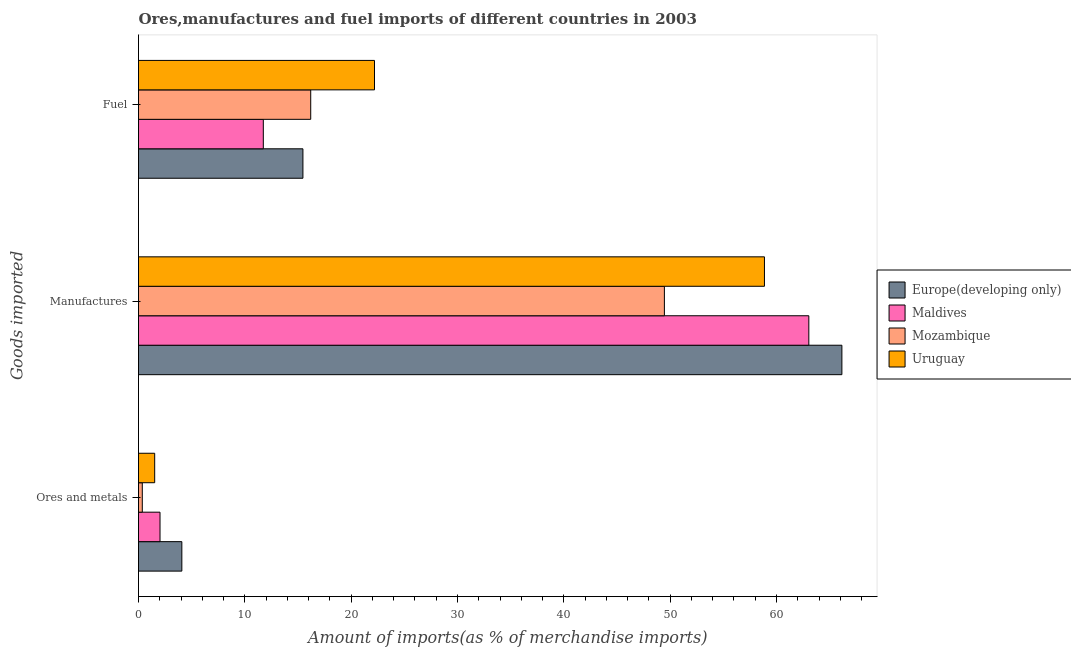How many different coloured bars are there?
Provide a short and direct response. 4. Are the number of bars per tick equal to the number of legend labels?
Give a very brief answer. Yes. Are the number of bars on each tick of the Y-axis equal?
Ensure brevity in your answer.  Yes. How many bars are there on the 3rd tick from the bottom?
Make the answer very short. 4. What is the label of the 1st group of bars from the top?
Make the answer very short. Fuel. What is the percentage of ores and metals imports in Maldives?
Give a very brief answer. 2.02. Across all countries, what is the maximum percentage of fuel imports?
Provide a succinct answer. 22.19. Across all countries, what is the minimum percentage of fuel imports?
Provide a succinct answer. 11.74. In which country was the percentage of fuel imports maximum?
Ensure brevity in your answer.  Uruguay. In which country was the percentage of ores and metals imports minimum?
Provide a short and direct response. Mozambique. What is the total percentage of fuel imports in the graph?
Your answer should be compact. 65.59. What is the difference between the percentage of fuel imports in Mozambique and that in Europe(developing only)?
Ensure brevity in your answer.  0.73. What is the difference between the percentage of ores and metals imports in Maldives and the percentage of fuel imports in Uruguay?
Give a very brief answer. -20.17. What is the average percentage of ores and metals imports per country?
Ensure brevity in your answer.  1.99. What is the difference between the percentage of manufactures imports and percentage of ores and metals imports in Europe(developing only)?
Offer a terse response. 62.07. What is the ratio of the percentage of manufactures imports in Maldives to that in Europe(developing only)?
Offer a very short reply. 0.95. What is the difference between the highest and the second highest percentage of ores and metals imports?
Offer a very short reply. 2.05. What is the difference between the highest and the lowest percentage of fuel imports?
Your answer should be very brief. 10.46. What does the 2nd bar from the top in Ores and metals represents?
Provide a short and direct response. Mozambique. What does the 3rd bar from the bottom in Ores and metals represents?
Your answer should be compact. Mozambique. Is it the case that in every country, the sum of the percentage of ores and metals imports and percentage of manufactures imports is greater than the percentage of fuel imports?
Your answer should be compact. Yes. Are all the bars in the graph horizontal?
Give a very brief answer. Yes. Where does the legend appear in the graph?
Your answer should be very brief. Center right. How many legend labels are there?
Provide a succinct answer. 4. What is the title of the graph?
Offer a very short reply. Ores,manufactures and fuel imports of different countries in 2003. What is the label or title of the X-axis?
Keep it short and to the point. Amount of imports(as % of merchandise imports). What is the label or title of the Y-axis?
Give a very brief answer. Goods imported. What is the Amount of imports(as % of merchandise imports) of Europe(developing only) in Ores and metals?
Offer a very short reply. 4.07. What is the Amount of imports(as % of merchandise imports) in Maldives in Ores and metals?
Provide a succinct answer. 2.02. What is the Amount of imports(as % of merchandise imports) in Mozambique in Ores and metals?
Provide a short and direct response. 0.36. What is the Amount of imports(as % of merchandise imports) of Uruguay in Ores and metals?
Offer a very short reply. 1.52. What is the Amount of imports(as % of merchandise imports) of Europe(developing only) in Manufactures?
Provide a succinct answer. 66.15. What is the Amount of imports(as % of merchandise imports) of Maldives in Manufactures?
Keep it short and to the point. 63.04. What is the Amount of imports(as % of merchandise imports) of Mozambique in Manufactures?
Keep it short and to the point. 49.46. What is the Amount of imports(as % of merchandise imports) of Uruguay in Manufactures?
Offer a terse response. 58.87. What is the Amount of imports(as % of merchandise imports) in Europe(developing only) in Fuel?
Your answer should be compact. 15.46. What is the Amount of imports(as % of merchandise imports) of Maldives in Fuel?
Provide a succinct answer. 11.74. What is the Amount of imports(as % of merchandise imports) in Mozambique in Fuel?
Keep it short and to the point. 16.2. What is the Amount of imports(as % of merchandise imports) in Uruguay in Fuel?
Provide a succinct answer. 22.19. Across all Goods imported, what is the maximum Amount of imports(as % of merchandise imports) in Europe(developing only)?
Your answer should be compact. 66.15. Across all Goods imported, what is the maximum Amount of imports(as % of merchandise imports) in Maldives?
Offer a terse response. 63.04. Across all Goods imported, what is the maximum Amount of imports(as % of merchandise imports) in Mozambique?
Your answer should be compact. 49.46. Across all Goods imported, what is the maximum Amount of imports(as % of merchandise imports) in Uruguay?
Your response must be concise. 58.87. Across all Goods imported, what is the minimum Amount of imports(as % of merchandise imports) in Europe(developing only)?
Provide a succinct answer. 4.07. Across all Goods imported, what is the minimum Amount of imports(as % of merchandise imports) of Maldives?
Give a very brief answer. 2.02. Across all Goods imported, what is the minimum Amount of imports(as % of merchandise imports) in Mozambique?
Your answer should be very brief. 0.36. Across all Goods imported, what is the minimum Amount of imports(as % of merchandise imports) of Uruguay?
Make the answer very short. 1.52. What is the total Amount of imports(as % of merchandise imports) of Europe(developing only) in the graph?
Provide a succinct answer. 85.69. What is the total Amount of imports(as % of merchandise imports) of Maldives in the graph?
Keep it short and to the point. 76.8. What is the total Amount of imports(as % of merchandise imports) in Mozambique in the graph?
Your answer should be compact. 66.01. What is the total Amount of imports(as % of merchandise imports) of Uruguay in the graph?
Give a very brief answer. 82.58. What is the difference between the Amount of imports(as % of merchandise imports) in Europe(developing only) in Ores and metals and that in Manufactures?
Provide a short and direct response. -62.07. What is the difference between the Amount of imports(as % of merchandise imports) of Maldives in Ores and metals and that in Manufactures?
Give a very brief answer. -61.02. What is the difference between the Amount of imports(as % of merchandise imports) in Mozambique in Ores and metals and that in Manufactures?
Make the answer very short. -49.1. What is the difference between the Amount of imports(as % of merchandise imports) in Uruguay in Ores and metals and that in Manufactures?
Your answer should be very brief. -57.34. What is the difference between the Amount of imports(as % of merchandise imports) of Europe(developing only) in Ores and metals and that in Fuel?
Offer a terse response. -11.39. What is the difference between the Amount of imports(as % of merchandise imports) of Maldives in Ores and metals and that in Fuel?
Offer a terse response. -9.71. What is the difference between the Amount of imports(as % of merchandise imports) of Mozambique in Ores and metals and that in Fuel?
Your answer should be very brief. -15.84. What is the difference between the Amount of imports(as % of merchandise imports) of Uruguay in Ores and metals and that in Fuel?
Offer a very short reply. -20.67. What is the difference between the Amount of imports(as % of merchandise imports) of Europe(developing only) in Manufactures and that in Fuel?
Your response must be concise. 50.69. What is the difference between the Amount of imports(as % of merchandise imports) of Maldives in Manufactures and that in Fuel?
Provide a short and direct response. 51.3. What is the difference between the Amount of imports(as % of merchandise imports) of Mozambique in Manufactures and that in Fuel?
Your response must be concise. 33.26. What is the difference between the Amount of imports(as % of merchandise imports) in Uruguay in Manufactures and that in Fuel?
Offer a very short reply. 36.67. What is the difference between the Amount of imports(as % of merchandise imports) in Europe(developing only) in Ores and metals and the Amount of imports(as % of merchandise imports) in Maldives in Manufactures?
Your answer should be very brief. -58.97. What is the difference between the Amount of imports(as % of merchandise imports) in Europe(developing only) in Ores and metals and the Amount of imports(as % of merchandise imports) in Mozambique in Manufactures?
Provide a succinct answer. -45.38. What is the difference between the Amount of imports(as % of merchandise imports) in Europe(developing only) in Ores and metals and the Amount of imports(as % of merchandise imports) in Uruguay in Manufactures?
Make the answer very short. -54.79. What is the difference between the Amount of imports(as % of merchandise imports) in Maldives in Ores and metals and the Amount of imports(as % of merchandise imports) in Mozambique in Manufactures?
Ensure brevity in your answer.  -47.43. What is the difference between the Amount of imports(as % of merchandise imports) of Maldives in Ores and metals and the Amount of imports(as % of merchandise imports) of Uruguay in Manufactures?
Offer a terse response. -56.84. What is the difference between the Amount of imports(as % of merchandise imports) in Mozambique in Ores and metals and the Amount of imports(as % of merchandise imports) in Uruguay in Manufactures?
Provide a short and direct response. -58.51. What is the difference between the Amount of imports(as % of merchandise imports) in Europe(developing only) in Ores and metals and the Amount of imports(as % of merchandise imports) in Maldives in Fuel?
Offer a very short reply. -7.66. What is the difference between the Amount of imports(as % of merchandise imports) in Europe(developing only) in Ores and metals and the Amount of imports(as % of merchandise imports) in Mozambique in Fuel?
Make the answer very short. -12.12. What is the difference between the Amount of imports(as % of merchandise imports) in Europe(developing only) in Ores and metals and the Amount of imports(as % of merchandise imports) in Uruguay in Fuel?
Make the answer very short. -18.12. What is the difference between the Amount of imports(as % of merchandise imports) of Maldives in Ores and metals and the Amount of imports(as % of merchandise imports) of Mozambique in Fuel?
Your answer should be very brief. -14.17. What is the difference between the Amount of imports(as % of merchandise imports) of Maldives in Ores and metals and the Amount of imports(as % of merchandise imports) of Uruguay in Fuel?
Offer a terse response. -20.17. What is the difference between the Amount of imports(as % of merchandise imports) in Mozambique in Ores and metals and the Amount of imports(as % of merchandise imports) in Uruguay in Fuel?
Your answer should be compact. -21.84. What is the difference between the Amount of imports(as % of merchandise imports) in Europe(developing only) in Manufactures and the Amount of imports(as % of merchandise imports) in Maldives in Fuel?
Offer a terse response. 54.41. What is the difference between the Amount of imports(as % of merchandise imports) in Europe(developing only) in Manufactures and the Amount of imports(as % of merchandise imports) in Mozambique in Fuel?
Provide a short and direct response. 49.95. What is the difference between the Amount of imports(as % of merchandise imports) of Europe(developing only) in Manufactures and the Amount of imports(as % of merchandise imports) of Uruguay in Fuel?
Provide a short and direct response. 43.95. What is the difference between the Amount of imports(as % of merchandise imports) of Maldives in Manufactures and the Amount of imports(as % of merchandise imports) of Mozambique in Fuel?
Your response must be concise. 46.84. What is the difference between the Amount of imports(as % of merchandise imports) in Maldives in Manufactures and the Amount of imports(as % of merchandise imports) in Uruguay in Fuel?
Make the answer very short. 40.85. What is the difference between the Amount of imports(as % of merchandise imports) in Mozambique in Manufactures and the Amount of imports(as % of merchandise imports) in Uruguay in Fuel?
Offer a very short reply. 27.26. What is the average Amount of imports(as % of merchandise imports) in Europe(developing only) per Goods imported?
Keep it short and to the point. 28.56. What is the average Amount of imports(as % of merchandise imports) of Maldives per Goods imported?
Ensure brevity in your answer.  25.6. What is the average Amount of imports(as % of merchandise imports) of Mozambique per Goods imported?
Offer a terse response. 22. What is the average Amount of imports(as % of merchandise imports) in Uruguay per Goods imported?
Provide a succinct answer. 27.53. What is the difference between the Amount of imports(as % of merchandise imports) in Europe(developing only) and Amount of imports(as % of merchandise imports) in Maldives in Ores and metals?
Provide a succinct answer. 2.05. What is the difference between the Amount of imports(as % of merchandise imports) in Europe(developing only) and Amount of imports(as % of merchandise imports) in Mozambique in Ores and metals?
Your answer should be very brief. 3.72. What is the difference between the Amount of imports(as % of merchandise imports) of Europe(developing only) and Amount of imports(as % of merchandise imports) of Uruguay in Ores and metals?
Provide a short and direct response. 2.55. What is the difference between the Amount of imports(as % of merchandise imports) in Maldives and Amount of imports(as % of merchandise imports) in Mozambique in Ores and metals?
Your answer should be compact. 1.67. What is the difference between the Amount of imports(as % of merchandise imports) in Maldives and Amount of imports(as % of merchandise imports) in Uruguay in Ores and metals?
Your answer should be compact. 0.5. What is the difference between the Amount of imports(as % of merchandise imports) of Mozambique and Amount of imports(as % of merchandise imports) of Uruguay in Ores and metals?
Ensure brevity in your answer.  -1.17. What is the difference between the Amount of imports(as % of merchandise imports) in Europe(developing only) and Amount of imports(as % of merchandise imports) in Maldives in Manufactures?
Make the answer very short. 3.11. What is the difference between the Amount of imports(as % of merchandise imports) of Europe(developing only) and Amount of imports(as % of merchandise imports) of Mozambique in Manufactures?
Your answer should be compact. 16.69. What is the difference between the Amount of imports(as % of merchandise imports) of Europe(developing only) and Amount of imports(as % of merchandise imports) of Uruguay in Manufactures?
Offer a terse response. 7.28. What is the difference between the Amount of imports(as % of merchandise imports) of Maldives and Amount of imports(as % of merchandise imports) of Mozambique in Manufactures?
Make the answer very short. 13.58. What is the difference between the Amount of imports(as % of merchandise imports) in Maldives and Amount of imports(as % of merchandise imports) in Uruguay in Manufactures?
Offer a very short reply. 4.17. What is the difference between the Amount of imports(as % of merchandise imports) of Mozambique and Amount of imports(as % of merchandise imports) of Uruguay in Manufactures?
Ensure brevity in your answer.  -9.41. What is the difference between the Amount of imports(as % of merchandise imports) in Europe(developing only) and Amount of imports(as % of merchandise imports) in Maldives in Fuel?
Provide a succinct answer. 3.73. What is the difference between the Amount of imports(as % of merchandise imports) of Europe(developing only) and Amount of imports(as % of merchandise imports) of Mozambique in Fuel?
Keep it short and to the point. -0.73. What is the difference between the Amount of imports(as % of merchandise imports) in Europe(developing only) and Amount of imports(as % of merchandise imports) in Uruguay in Fuel?
Your response must be concise. -6.73. What is the difference between the Amount of imports(as % of merchandise imports) of Maldives and Amount of imports(as % of merchandise imports) of Mozambique in Fuel?
Offer a very short reply. -4.46. What is the difference between the Amount of imports(as % of merchandise imports) of Maldives and Amount of imports(as % of merchandise imports) of Uruguay in Fuel?
Offer a very short reply. -10.46. What is the difference between the Amount of imports(as % of merchandise imports) in Mozambique and Amount of imports(as % of merchandise imports) in Uruguay in Fuel?
Make the answer very short. -6. What is the ratio of the Amount of imports(as % of merchandise imports) of Europe(developing only) in Ores and metals to that in Manufactures?
Keep it short and to the point. 0.06. What is the ratio of the Amount of imports(as % of merchandise imports) in Maldives in Ores and metals to that in Manufactures?
Provide a succinct answer. 0.03. What is the ratio of the Amount of imports(as % of merchandise imports) of Mozambique in Ores and metals to that in Manufactures?
Provide a short and direct response. 0.01. What is the ratio of the Amount of imports(as % of merchandise imports) of Uruguay in Ores and metals to that in Manufactures?
Offer a terse response. 0.03. What is the ratio of the Amount of imports(as % of merchandise imports) in Europe(developing only) in Ores and metals to that in Fuel?
Your answer should be compact. 0.26. What is the ratio of the Amount of imports(as % of merchandise imports) in Maldives in Ores and metals to that in Fuel?
Give a very brief answer. 0.17. What is the ratio of the Amount of imports(as % of merchandise imports) of Mozambique in Ores and metals to that in Fuel?
Keep it short and to the point. 0.02. What is the ratio of the Amount of imports(as % of merchandise imports) in Uruguay in Ores and metals to that in Fuel?
Your answer should be compact. 0.07. What is the ratio of the Amount of imports(as % of merchandise imports) of Europe(developing only) in Manufactures to that in Fuel?
Give a very brief answer. 4.28. What is the ratio of the Amount of imports(as % of merchandise imports) in Maldives in Manufactures to that in Fuel?
Give a very brief answer. 5.37. What is the ratio of the Amount of imports(as % of merchandise imports) of Mozambique in Manufactures to that in Fuel?
Offer a terse response. 3.05. What is the ratio of the Amount of imports(as % of merchandise imports) in Uruguay in Manufactures to that in Fuel?
Your response must be concise. 2.65. What is the difference between the highest and the second highest Amount of imports(as % of merchandise imports) of Europe(developing only)?
Your answer should be compact. 50.69. What is the difference between the highest and the second highest Amount of imports(as % of merchandise imports) in Maldives?
Your answer should be compact. 51.3. What is the difference between the highest and the second highest Amount of imports(as % of merchandise imports) of Mozambique?
Provide a succinct answer. 33.26. What is the difference between the highest and the second highest Amount of imports(as % of merchandise imports) in Uruguay?
Keep it short and to the point. 36.67. What is the difference between the highest and the lowest Amount of imports(as % of merchandise imports) of Europe(developing only)?
Offer a very short reply. 62.07. What is the difference between the highest and the lowest Amount of imports(as % of merchandise imports) of Maldives?
Your answer should be very brief. 61.02. What is the difference between the highest and the lowest Amount of imports(as % of merchandise imports) of Mozambique?
Offer a terse response. 49.1. What is the difference between the highest and the lowest Amount of imports(as % of merchandise imports) of Uruguay?
Provide a succinct answer. 57.34. 